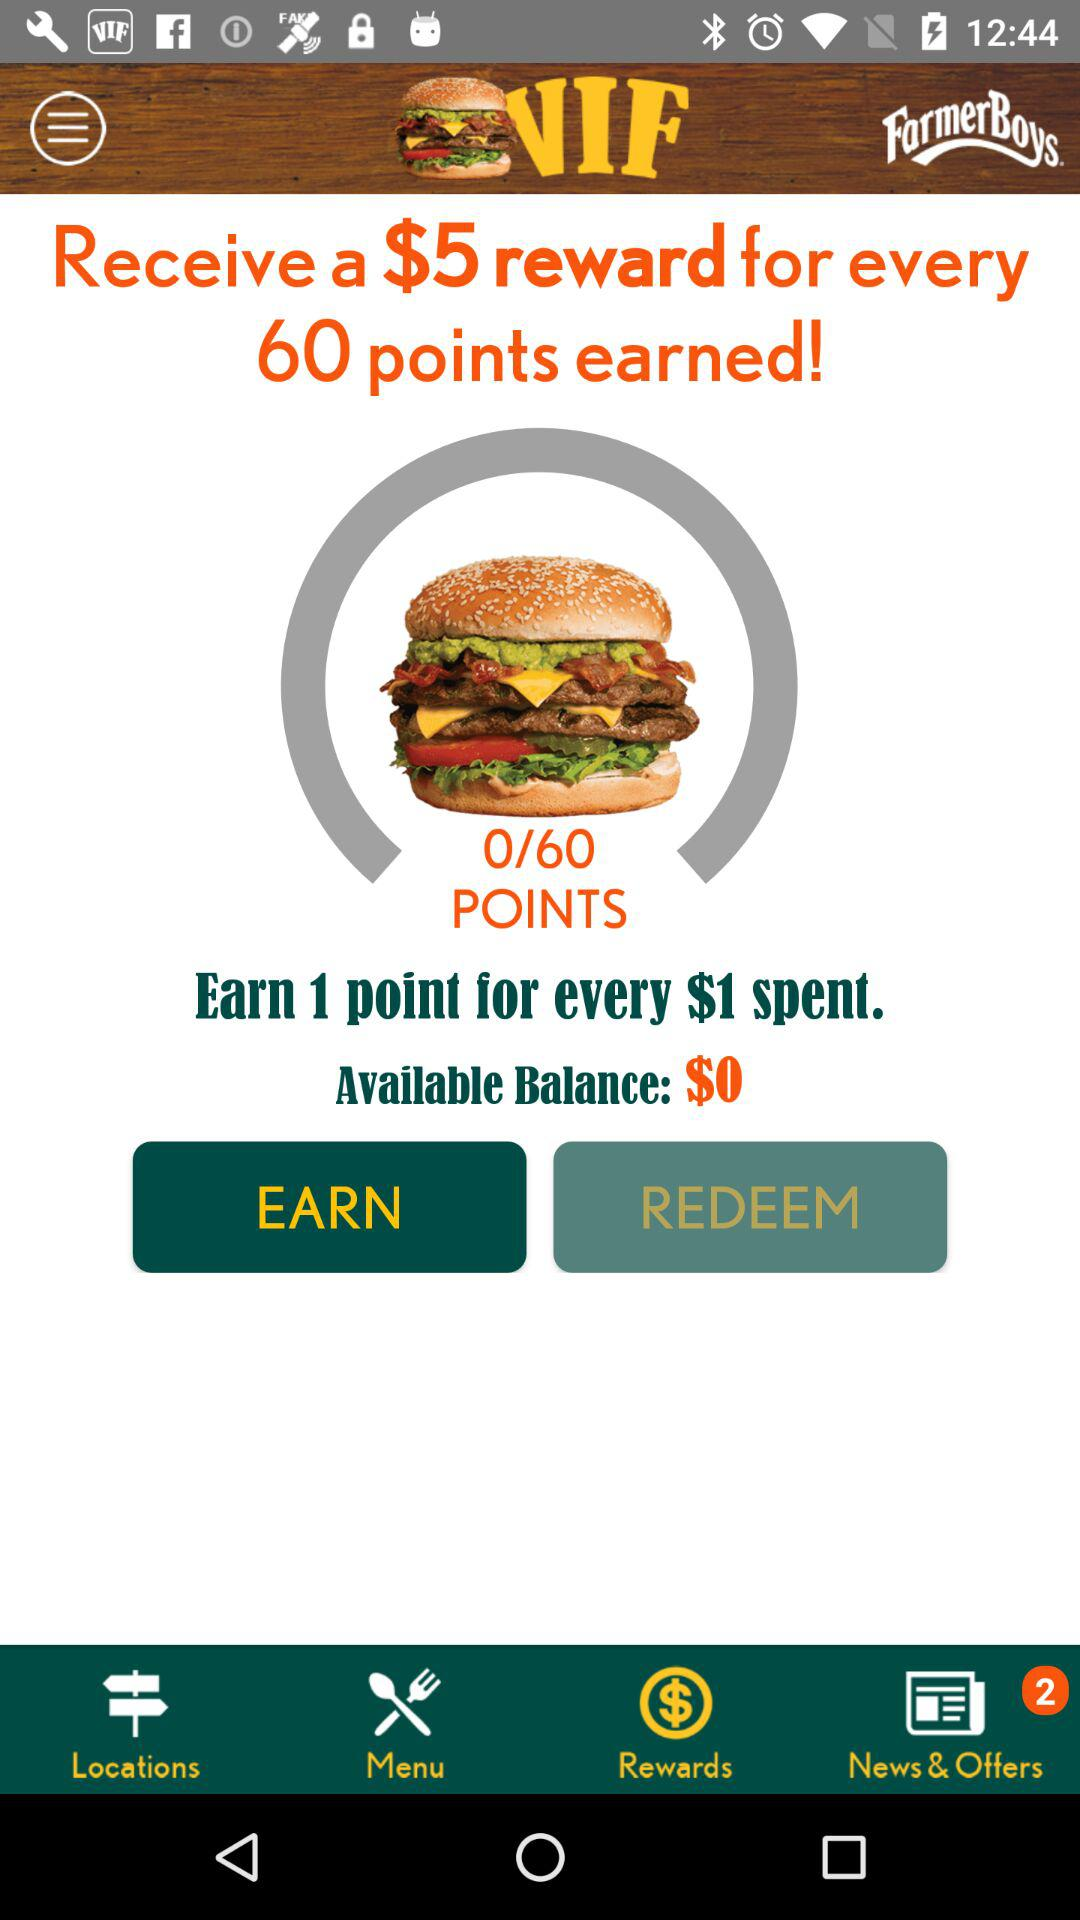Which option is selected? The selected option is "EARN". 